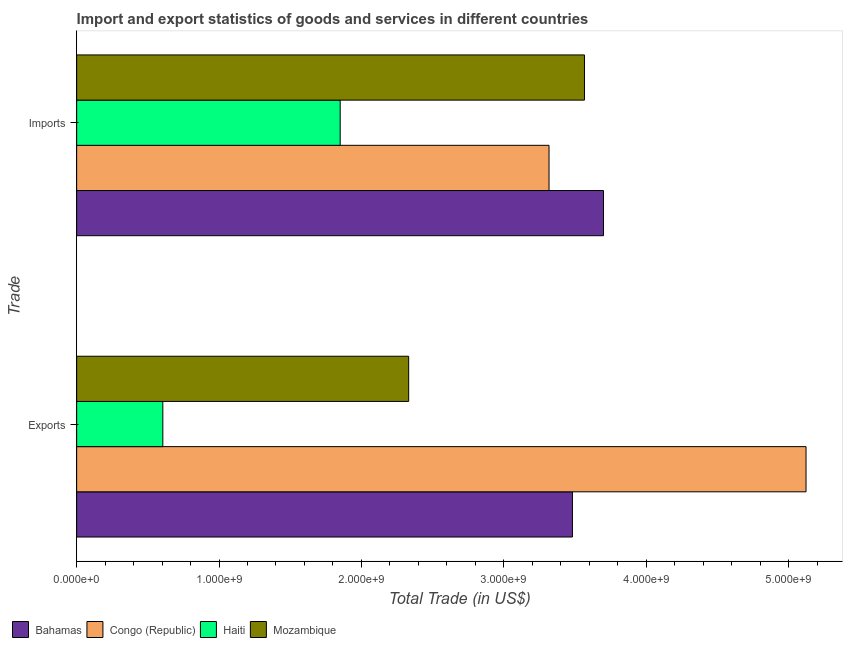How many different coloured bars are there?
Provide a short and direct response. 4. How many bars are there on the 2nd tick from the top?
Your answer should be compact. 4. What is the label of the 2nd group of bars from the top?
Give a very brief answer. Exports. What is the export of goods and services in Haiti?
Give a very brief answer. 6.05e+08. Across all countries, what is the maximum export of goods and services?
Your answer should be very brief. 5.12e+09. Across all countries, what is the minimum export of goods and services?
Keep it short and to the point. 6.05e+08. In which country was the imports of goods and services maximum?
Your response must be concise. Bahamas. In which country was the imports of goods and services minimum?
Your answer should be compact. Haiti. What is the total export of goods and services in the graph?
Provide a short and direct response. 1.15e+1. What is the difference between the export of goods and services in Bahamas and that in Mozambique?
Offer a terse response. 1.15e+09. What is the difference between the export of goods and services in Mozambique and the imports of goods and services in Haiti?
Provide a succinct answer. 4.81e+08. What is the average export of goods and services per country?
Make the answer very short. 2.89e+09. What is the difference between the export of goods and services and imports of goods and services in Mozambique?
Give a very brief answer. -1.23e+09. What is the ratio of the imports of goods and services in Haiti to that in Mozambique?
Ensure brevity in your answer.  0.52. In how many countries, is the export of goods and services greater than the average export of goods and services taken over all countries?
Ensure brevity in your answer.  2. What does the 3rd bar from the top in Imports represents?
Provide a succinct answer. Congo (Republic). What does the 4th bar from the bottom in Imports represents?
Provide a short and direct response. Mozambique. How many countries are there in the graph?
Offer a terse response. 4. What is the difference between two consecutive major ticks on the X-axis?
Keep it short and to the point. 1.00e+09. How are the legend labels stacked?
Give a very brief answer. Horizontal. What is the title of the graph?
Give a very brief answer. Import and export statistics of goods and services in different countries. What is the label or title of the X-axis?
Your answer should be compact. Total Trade (in US$). What is the label or title of the Y-axis?
Offer a terse response. Trade. What is the Total Trade (in US$) in Bahamas in Exports?
Your answer should be compact. 3.48e+09. What is the Total Trade (in US$) of Congo (Republic) in Exports?
Ensure brevity in your answer.  5.12e+09. What is the Total Trade (in US$) of Haiti in Exports?
Provide a short and direct response. 6.05e+08. What is the Total Trade (in US$) in Mozambique in Exports?
Give a very brief answer. 2.33e+09. What is the Total Trade (in US$) in Bahamas in Imports?
Make the answer very short. 3.70e+09. What is the Total Trade (in US$) in Congo (Republic) in Imports?
Keep it short and to the point. 3.32e+09. What is the Total Trade (in US$) of Haiti in Imports?
Offer a very short reply. 1.85e+09. What is the Total Trade (in US$) of Mozambique in Imports?
Offer a very short reply. 3.57e+09. Across all Trade, what is the maximum Total Trade (in US$) in Bahamas?
Your answer should be compact. 3.70e+09. Across all Trade, what is the maximum Total Trade (in US$) in Congo (Republic)?
Your answer should be compact. 5.12e+09. Across all Trade, what is the maximum Total Trade (in US$) of Haiti?
Give a very brief answer. 1.85e+09. Across all Trade, what is the maximum Total Trade (in US$) in Mozambique?
Ensure brevity in your answer.  3.57e+09. Across all Trade, what is the minimum Total Trade (in US$) in Bahamas?
Offer a very short reply. 3.48e+09. Across all Trade, what is the minimum Total Trade (in US$) of Congo (Republic)?
Make the answer very short. 3.32e+09. Across all Trade, what is the minimum Total Trade (in US$) in Haiti?
Make the answer very short. 6.05e+08. Across all Trade, what is the minimum Total Trade (in US$) of Mozambique?
Offer a terse response. 2.33e+09. What is the total Total Trade (in US$) of Bahamas in the graph?
Offer a terse response. 7.18e+09. What is the total Total Trade (in US$) of Congo (Republic) in the graph?
Make the answer very short. 8.44e+09. What is the total Total Trade (in US$) of Haiti in the graph?
Offer a terse response. 2.46e+09. What is the total Total Trade (in US$) in Mozambique in the graph?
Ensure brevity in your answer.  5.90e+09. What is the difference between the Total Trade (in US$) of Bahamas in Exports and that in Imports?
Keep it short and to the point. -2.18e+08. What is the difference between the Total Trade (in US$) of Congo (Republic) in Exports and that in Imports?
Your answer should be compact. 1.80e+09. What is the difference between the Total Trade (in US$) of Haiti in Exports and that in Imports?
Offer a very short reply. -1.25e+09. What is the difference between the Total Trade (in US$) of Mozambique in Exports and that in Imports?
Your answer should be very brief. -1.23e+09. What is the difference between the Total Trade (in US$) in Bahamas in Exports and the Total Trade (in US$) in Congo (Republic) in Imports?
Provide a succinct answer. 1.64e+08. What is the difference between the Total Trade (in US$) of Bahamas in Exports and the Total Trade (in US$) of Haiti in Imports?
Keep it short and to the point. 1.63e+09. What is the difference between the Total Trade (in US$) of Bahamas in Exports and the Total Trade (in US$) of Mozambique in Imports?
Offer a terse response. -8.45e+07. What is the difference between the Total Trade (in US$) in Congo (Republic) in Exports and the Total Trade (in US$) in Haiti in Imports?
Your response must be concise. 3.27e+09. What is the difference between the Total Trade (in US$) of Congo (Republic) in Exports and the Total Trade (in US$) of Mozambique in Imports?
Your response must be concise. 1.56e+09. What is the difference between the Total Trade (in US$) of Haiti in Exports and the Total Trade (in US$) of Mozambique in Imports?
Keep it short and to the point. -2.96e+09. What is the average Total Trade (in US$) in Bahamas per Trade?
Provide a succinct answer. 3.59e+09. What is the average Total Trade (in US$) of Congo (Republic) per Trade?
Your answer should be compact. 4.22e+09. What is the average Total Trade (in US$) of Haiti per Trade?
Your response must be concise. 1.23e+09. What is the average Total Trade (in US$) in Mozambique per Trade?
Your answer should be compact. 2.95e+09. What is the difference between the Total Trade (in US$) of Bahamas and Total Trade (in US$) of Congo (Republic) in Exports?
Give a very brief answer. -1.64e+09. What is the difference between the Total Trade (in US$) in Bahamas and Total Trade (in US$) in Haiti in Exports?
Offer a terse response. 2.88e+09. What is the difference between the Total Trade (in US$) of Bahamas and Total Trade (in US$) of Mozambique in Exports?
Your response must be concise. 1.15e+09. What is the difference between the Total Trade (in US$) in Congo (Republic) and Total Trade (in US$) in Haiti in Exports?
Your answer should be compact. 4.52e+09. What is the difference between the Total Trade (in US$) of Congo (Republic) and Total Trade (in US$) of Mozambique in Exports?
Keep it short and to the point. 2.79e+09. What is the difference between the Total Trade (in US$) of Haiti and Total Trade (in US$) of Mozambique in Exports?
Provide a short and direct response. -1.73e+09. What is the difference between the Total Trade (in US$) of Bahamas and Total Trade (in US$) of Congo (Republic) in Imports?
Provide a succinct answer. 3.82e+08. What is the difference between the Total Trade (in US$) in Bahamas and Total Trade (in US$) in Haiti in Imports?
Offer a terse response. 1.85e+09. What is the difference between the Total Trade (in US$) of Bahamas and Total Trade (in US$) of Mozambique in Imports?
Your answer should be compact. 1.33e+08. What is the difference between the Total Trade (in US$) in Congo (Republic) and Total Trade (in US$) in Haiti in Imports?
Your answer should be compact. 1.47e+09. What is the difference between the Total Trade (in US$) of Congo (Republic) and Total Trade (in US$) of Mozambique in Imports?
Give a very brief answer. -2.49e+08. What is the difference between the Total Trade (in US$) in Haiti and Total Trade (in US$) in Mozambique in Imports?
Give a very brief answer. -1.72e+09. What is the ratio of the Total Trade (in US$) in Bahamas in Exports to that in Imports?
Your answer should be very brief. 0.94. What is the ratio of the Total Trade (in US$) of Congo (Republic) in Exports to that in Imports?
Keep it short and to the point. 1.54. What is the ratio of the Total Trade (in US$) of Haiti in Exports to that in Imports?
Provide a succinct answer. 0.33. What is the ratio of the Total Trade (in US$) of Mozambique in Exports to that in Imports?
Ensure brevity in your answer.  0.65. What is the difference between the highest and the second highest Total Trade (in US$) of Bahamas?
Keep it short and to the point. 2.18e+08. What is the difference between the highest and the second highest Total Trade (in US$) in Congo (Republic)?
Your answer should be very brief. 1.80e+09. What is the difference between the highest and the second highest Total Trade (in US$) of Haiti?
Your response must be concise. 1.25e+09. What is the difference between the highest and the second highest Total Trade (in US$) of Mozambique?
Offer a very short reply. 1.23e+09. What is the difference between the highest and the lowest Total Trade (in US$) in Bahamas?
Give a very brief answer. 2.18e+08. What is the difference between the highest and the lowest Total Trade (in US$) of Congo (Republic)?
Make the answer very short. 1.80e+09. What is the difference between the highest and the lowest Total Trade (in US$) in Haiti?
Make the answer very short. 1.25e+09. What is the difference between the highest and the lowest Total Trade (in US$) of Mozambique?
Ensure brevity in your answer.  1.23e+09. 